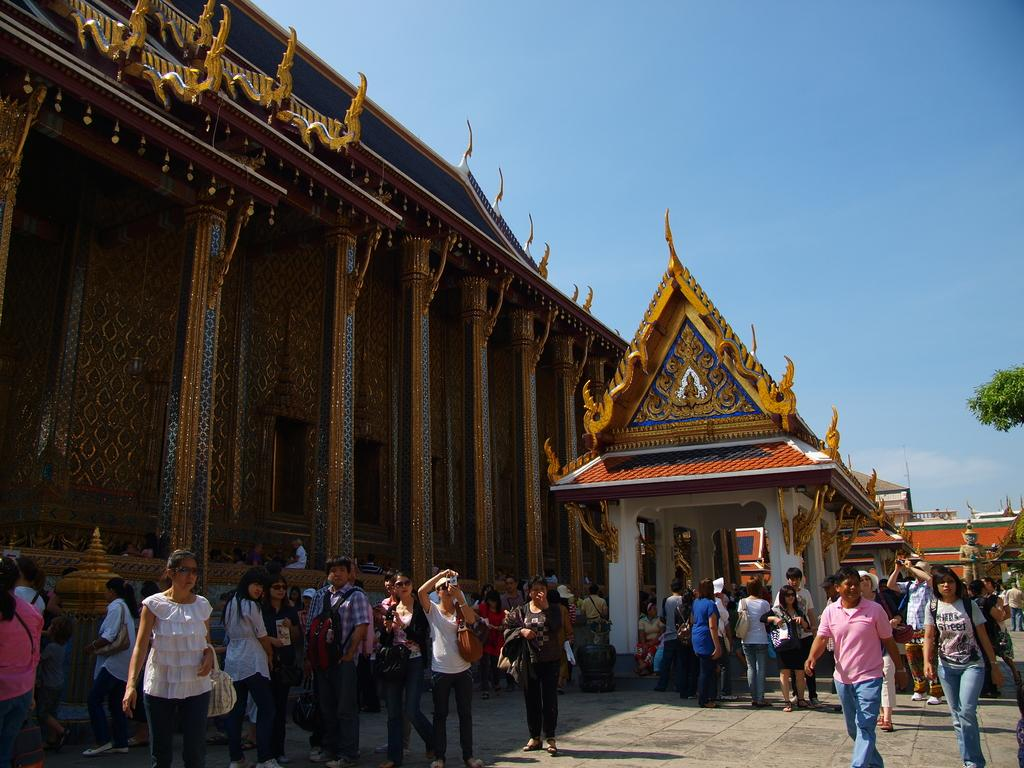What type of architecture is featured in the image? There is ancient Chinese architecture in the image. What structural elements can be seen in the image? There are pillars in the image. Who or what is present in the image? There are people in the image. What type of vegetation is visible in the image? There are leaves in the image. What is visible in the background of the image? The sky is visible in the image. What type of bottle can be seen in the hands of the people in the image? There is no bottle visible in the hands of the people in the image. Can you describe the rock formation in the background of the image? There is no rock formation present in the image; it features ancient Chinese architecture, pillars, people, leaves, and the sky. 